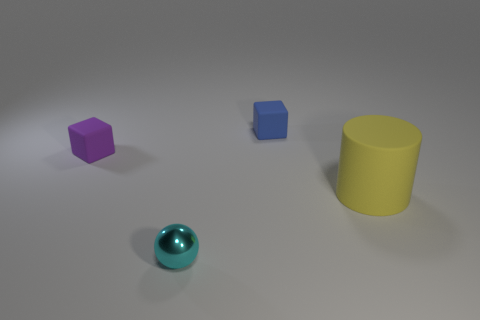Are there fewer purple rubber objects on the right side of the tiny shiny thing than objects that are left of the blue cube?
Offer a very short reply. Yes. What shape is the small thing that is in front of the matte cylinder in front of the object that is behind the small purple matte cube?
Your answer should be very brief. Sphere. Is the color of the cube to the right of the purple block the same as the tiny thing that is in front of the tiny purple rubber thing?
Offer a very short reply. No. How many rubber things are either purple spheres or small blocks?
Your answer should be compact. 2. There is a thing that is right of the tiny block that is behind the small rubber object in front of the blue matte thing; what color is it?
Give a very brief answer. Yellow. There is another rubber thing that is the same shape as the blue object; what is its color?
Provide a short and direct response. Purple. Are there any other things of the same color as the tiny metal sphere?
Ensure brevity in your answer.  No. How many other things are made of the same material as the large yellow cylinder?
Give a very brief answer. 2. What size is the purple rubber block?
Provide a succinct answer. Small. Are there any small blue matte objects of the same shape as the yellow object?
Provide a short and direct response. No. 